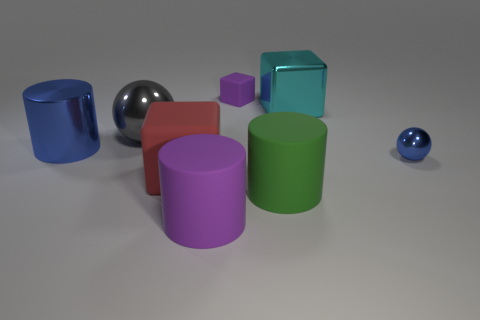Subtract all gray spheres. How many spheres are left? 1 Subtract all cylinders. How many objects are left? 5 Subtract all cyan spheres. How many blue cylinders are left? 1 Subtract all big green cylinders. How many cylinders are left? 2 Subtract 1 cylinders. How many cylinders are left? 2 Subtract all gray cylinders. Subtract all cyan blocks. How many cylinders are left? 3 Subtract all big red balls. Subtract all tiny objects. How many objects are left? 6 Add 7 gray shiny balls. How many gray shiny balls are left? 8 Add 5 green matte cylinders. How many green matte cylinders exist? 6 Add 1 small blue things. How many objects exist? 9 